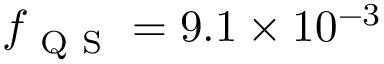<formula> <loc_0><loc_0><loc_500><loc_500>f _ { Q S } = 9 . 1 \times 1 0 ^ { - 3 }</formula> 